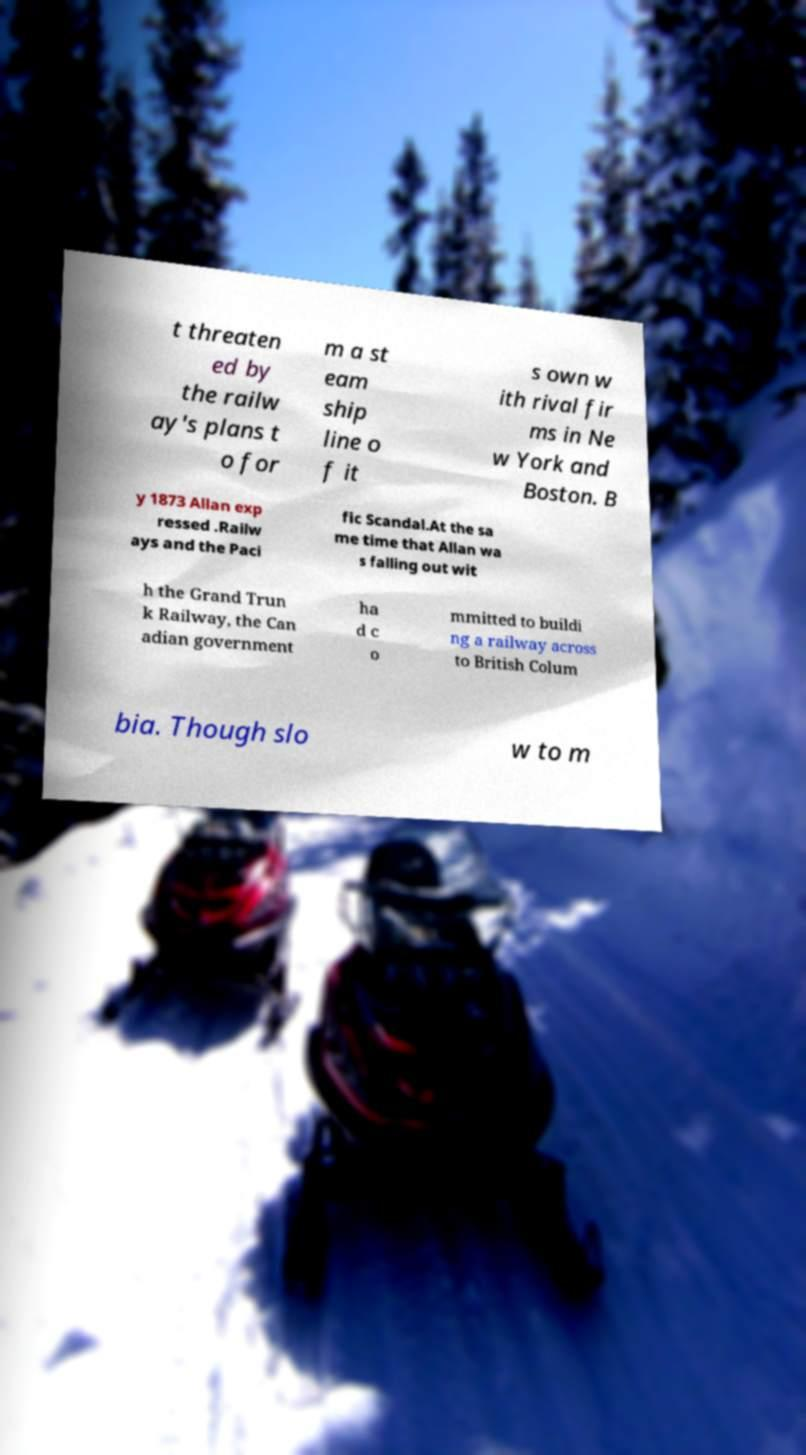Can you accurately transcribe the text from the provided image for me? t threaten ed by the railw ay's plans t o for m a st eam ship line o f it s own w ith rival fir ms in Ne w York and Boston. B y 1873 Allan exp ressed .Railw ays and the Paci fic Scandal.At the sa me time that Allan wa s falling out wit h the Grand Trun k Railway, the Can adian government ha d c o mmitted to buildi ng a railway across to British Colum bia. Though slo w to m 